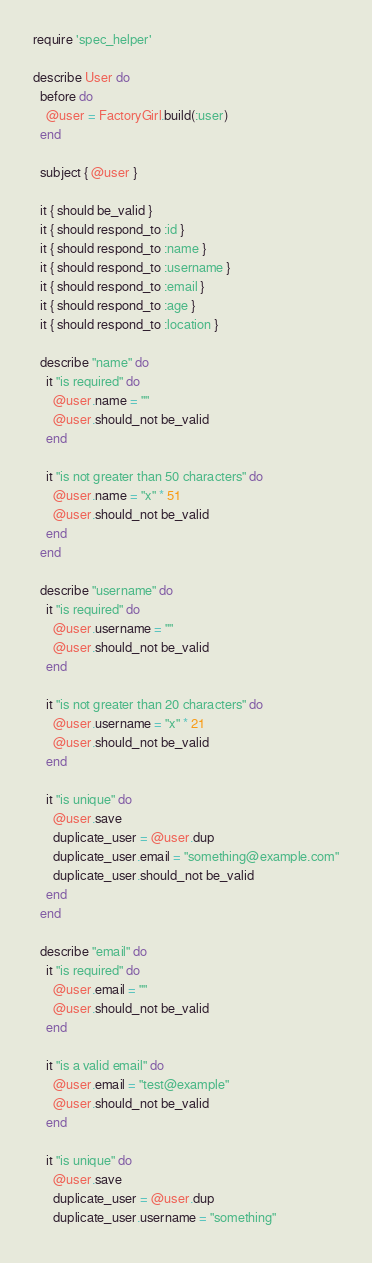Convert code to text. <code><loc_0><loc_0><loc_500><loc_500><_Ruby_>require 'spec_helper'

describe User do
  before do
    @user = FactoryGirl.build(:user)
  end

  subject { @user }

  it { should be_valid }
  it { should respond_to :id }
  it { should respond_to :name }
  it { should respond_to :username }
  it { should respond_to :email }
  it { should respond_to :age }
  it { should respond_to :location }

  describe "name" do
    it "is required" do
      @user.name = ""
      @user.should_not be_valid
    end

    it "is not greater than 50 characters" do
      @user.name = "x" * 51
      @user.should_not be_valid
    end
  end

  describe "username" do
    it "is required" do
      @user.username = ""
      @user.should_not be_valid
    end

    it "is not greater than 20 characters" do
      @user.username = "x" * 21
      @user.should_not be_valid
    end

    it "is unique" do
      @user.save
      duplicate_user = @user.dup
      duplicate_user.email = "something@example.com"
      duplicate_user.should_not be_valid
    end
  end

  describe "email" do
    it "is required" do
      @user.email = ""
      @user.should_not be_valid
    end

    it "is a valid email" do
      @user.email = "test@example"
      @user.should_not be_valid
    end

    it "is unique" do
      @user.save
      duplicate_user = @user.dup
      duplicate_user.username = "something"</code> 